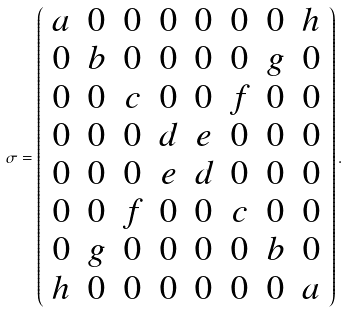Convert formula to latex. <formula><loc_0><loc_0><loc_500><loc_500>\sigma = \left ( \begin{array} { c c c c c c c c } a & 0 & 0 & 0 & 0 & 0 & 0 & h \\ 0 & b & 0 & 0 & 0 & 0 & g & 0 \\ 0 & 0 & c & 0 & 0 & f & 0 & 0 \\ 0 & 0 & 0 & d & e & 0 & 0 & 0 \\ 0 & 0 & 0 & e & d & 0 & 0 & 0 \\ 0 & 0 & f & 0 & 0 & c & 0 & 0 \\ 0 & g & 0 & 0 & 0 & 0 & b & 0 \\ h & 0 & 0 & 0 & 0 & 0 & 0 & a \end{array} \right ) .</formula> 